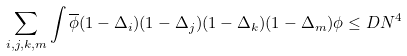Convert formula to latex. <formula><loc_0><loc_0><loc_500><loc_500>\sum _ { i , j , k , m } \int \overline { \phi } ( 1 - \Delta _ { i } ) ( 1 - \Delta _ { j } ) ( 1 - \Delta _ { k } ) ( 1 - \Delta _ { m } ) \phi \leq D N ^ { 4 }</formula> 